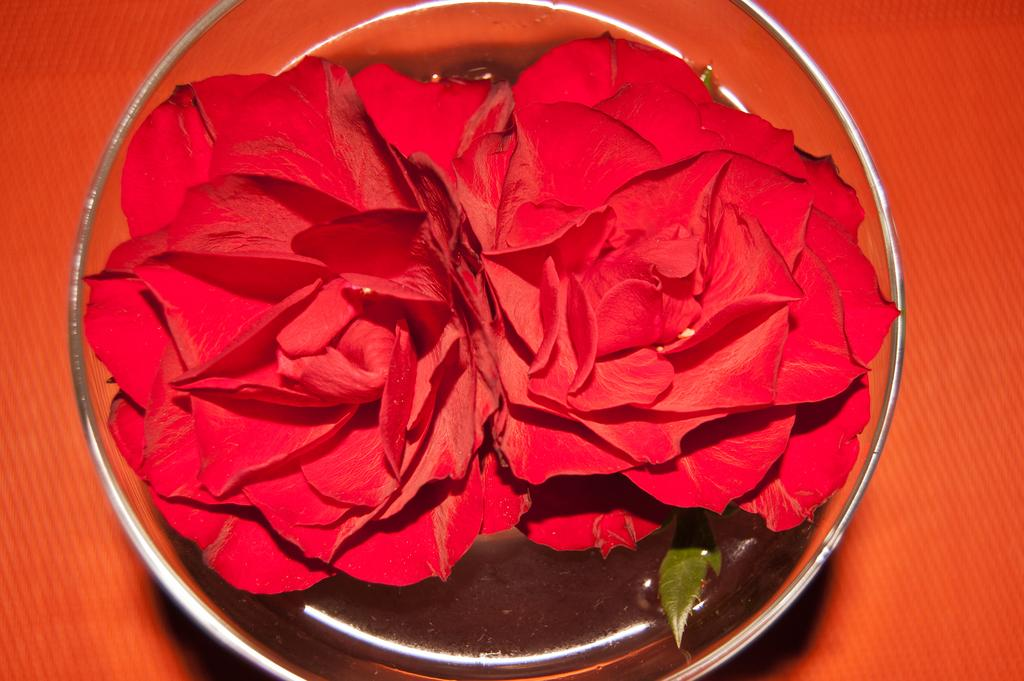What type of flowers are in the image? There are red roses in the image. How are the red roses displayed in the image? The red roses are in a glass. What is the color of the surface the glass is placed on? The glass is on an orange surface. What type of frame surrounds the red roses in the image? There is no frame surrounding the red roses in the image; they are simply in a glass. 